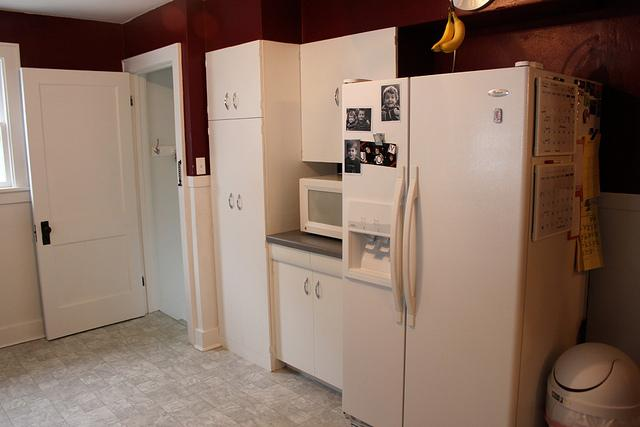What is the state of the bananas? Please explain your reasoning. ripe. The bananas are ripe. 